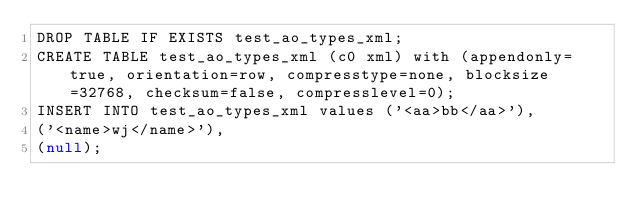<code> <loc_0><loc_0><loc_500><loc_500><_SQL_>DROP TABLE IF EXISTS test_ao_types_xml;
CREATE TABLE test_ao_types_xml (c0 xml) with (appendonly=true, orientation=row, compresstype=none, blocksize=32768, checksum=false, compresslevel=0);
INSERT INTO test_ao_types_xml values ('<aa>bb</aa>'),
('<name>wj</name>'),
(null);</code> 